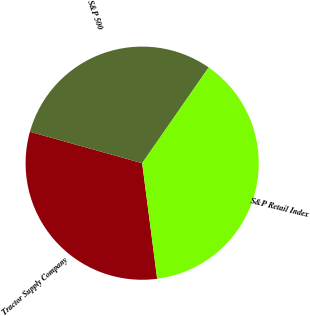<chart> <loc_0><loc_0><loc_500><loc_500><pie_chart><fcel>Tractor Supply Company<fcel>S&P 500<fcel>S&P Retail Index<nl><fcel>31.4%<fcel>30.32%<fcel>38.29%<nl></chart> 